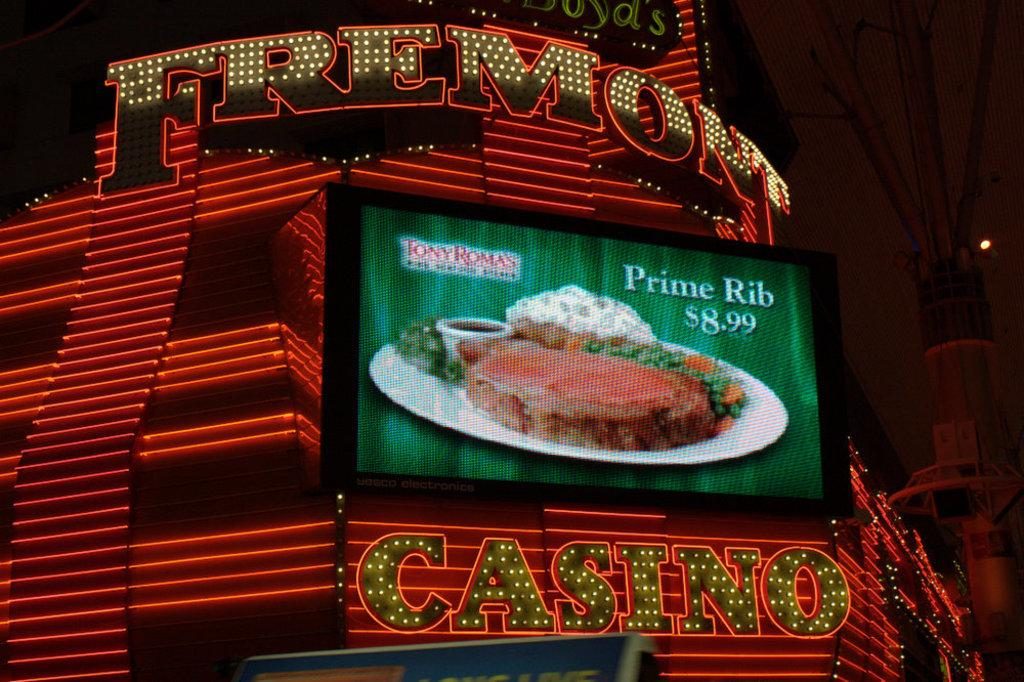What is attached to the wall of the building in the image? There is a screen attached to the wall of the building in the image. What is displayed on the screen? The screen displays a plate with food and a bowl. What can be seen on the right side of the image? There is a tower on the right side of the image. What is visible in the background of the image? The sky is visible in the background of the image. What type of wave can be seen crashing against the building in the image? There is no wave present in the image; it features a building with a screen and a tower. What is the reason for the protest happening in front of the building in the image? There is no protest present in the image; it only shows a building with a screen and a tower. 